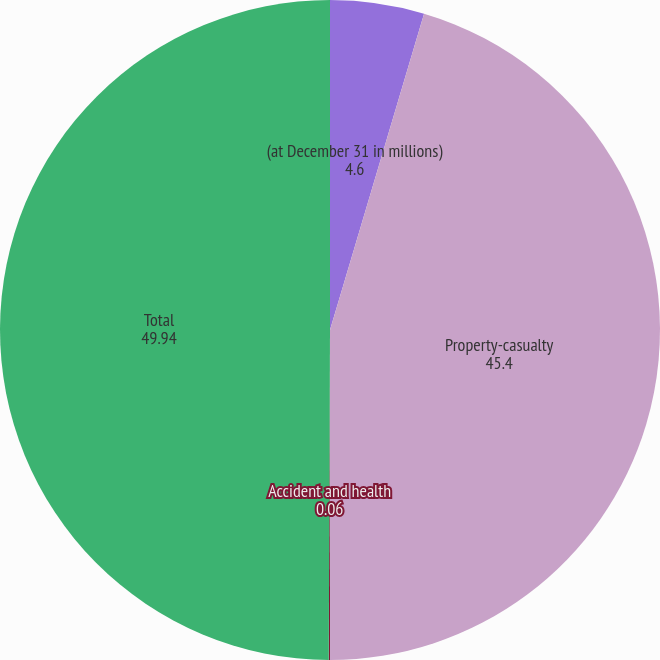Convert chart. <chart><loc_0><loc_0><loc_500><loc_500><pie_chart><fcel>(at December 31 in millions)<fcel>Property-casualty<fcel>Accident and health<fcel>Total<nl><fcel>4.6%<fcel>45.4%<fcel>0.06%<fcel>49.94%<nl></chart> 